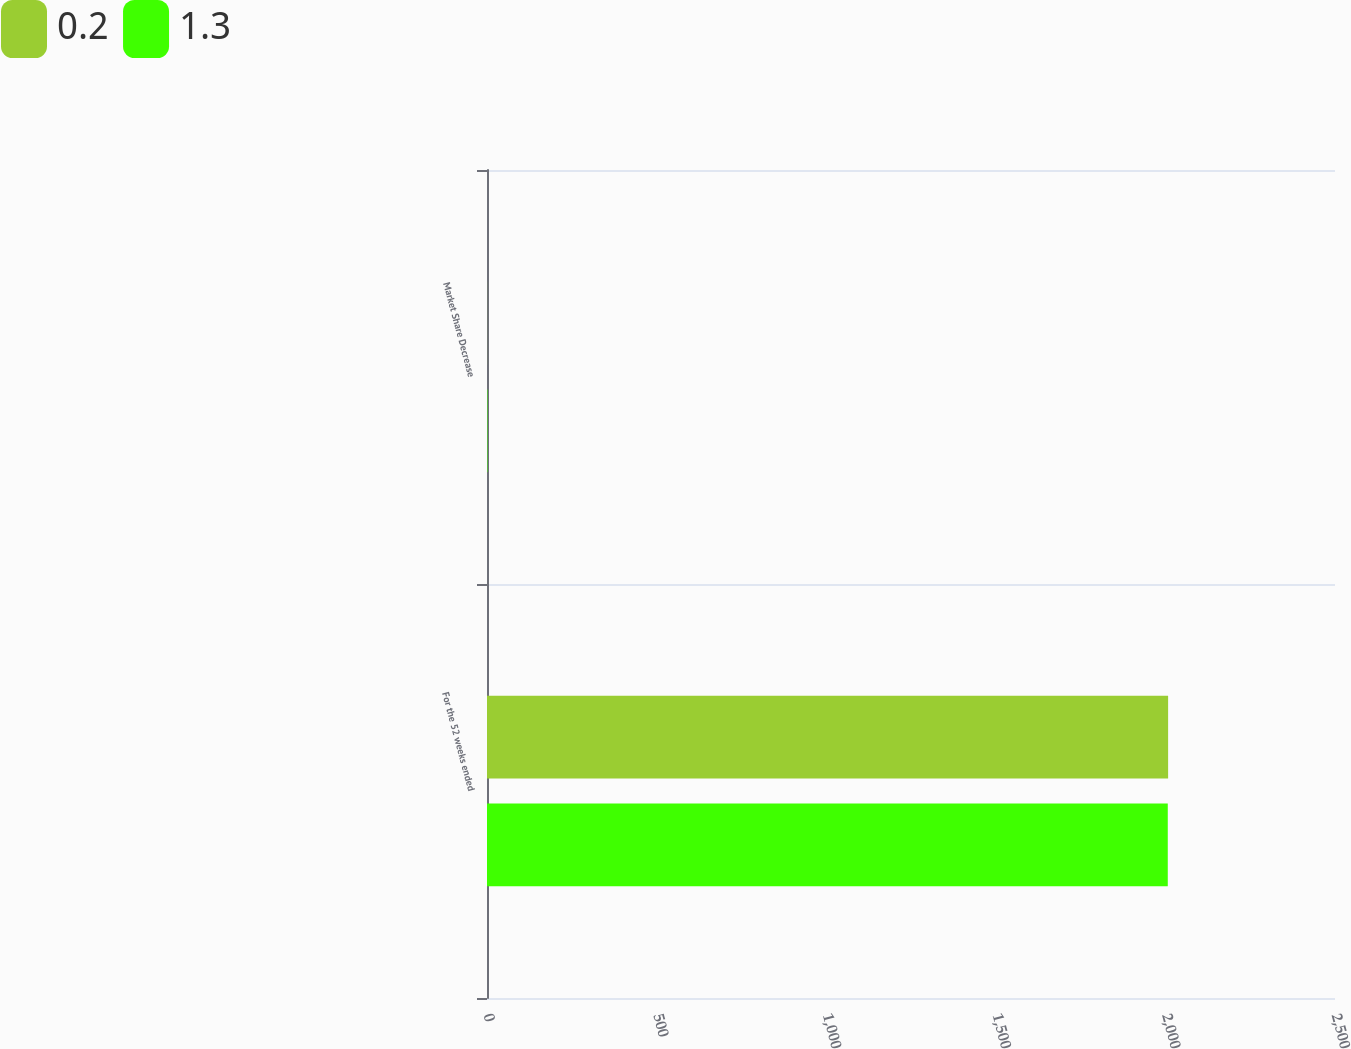Convert chart. <chart><loc_0><loc_0><loc_500><loc_500><stacked_bar_chart><ecel><fcel>For the 52 weeks ended<fcel>Market Share Decrease<nl><fcel>0.2<fcel>2008<fcel>0.2<nl><fcel>1.3<fcel>2007<fcel>1.3<nl></chart> 